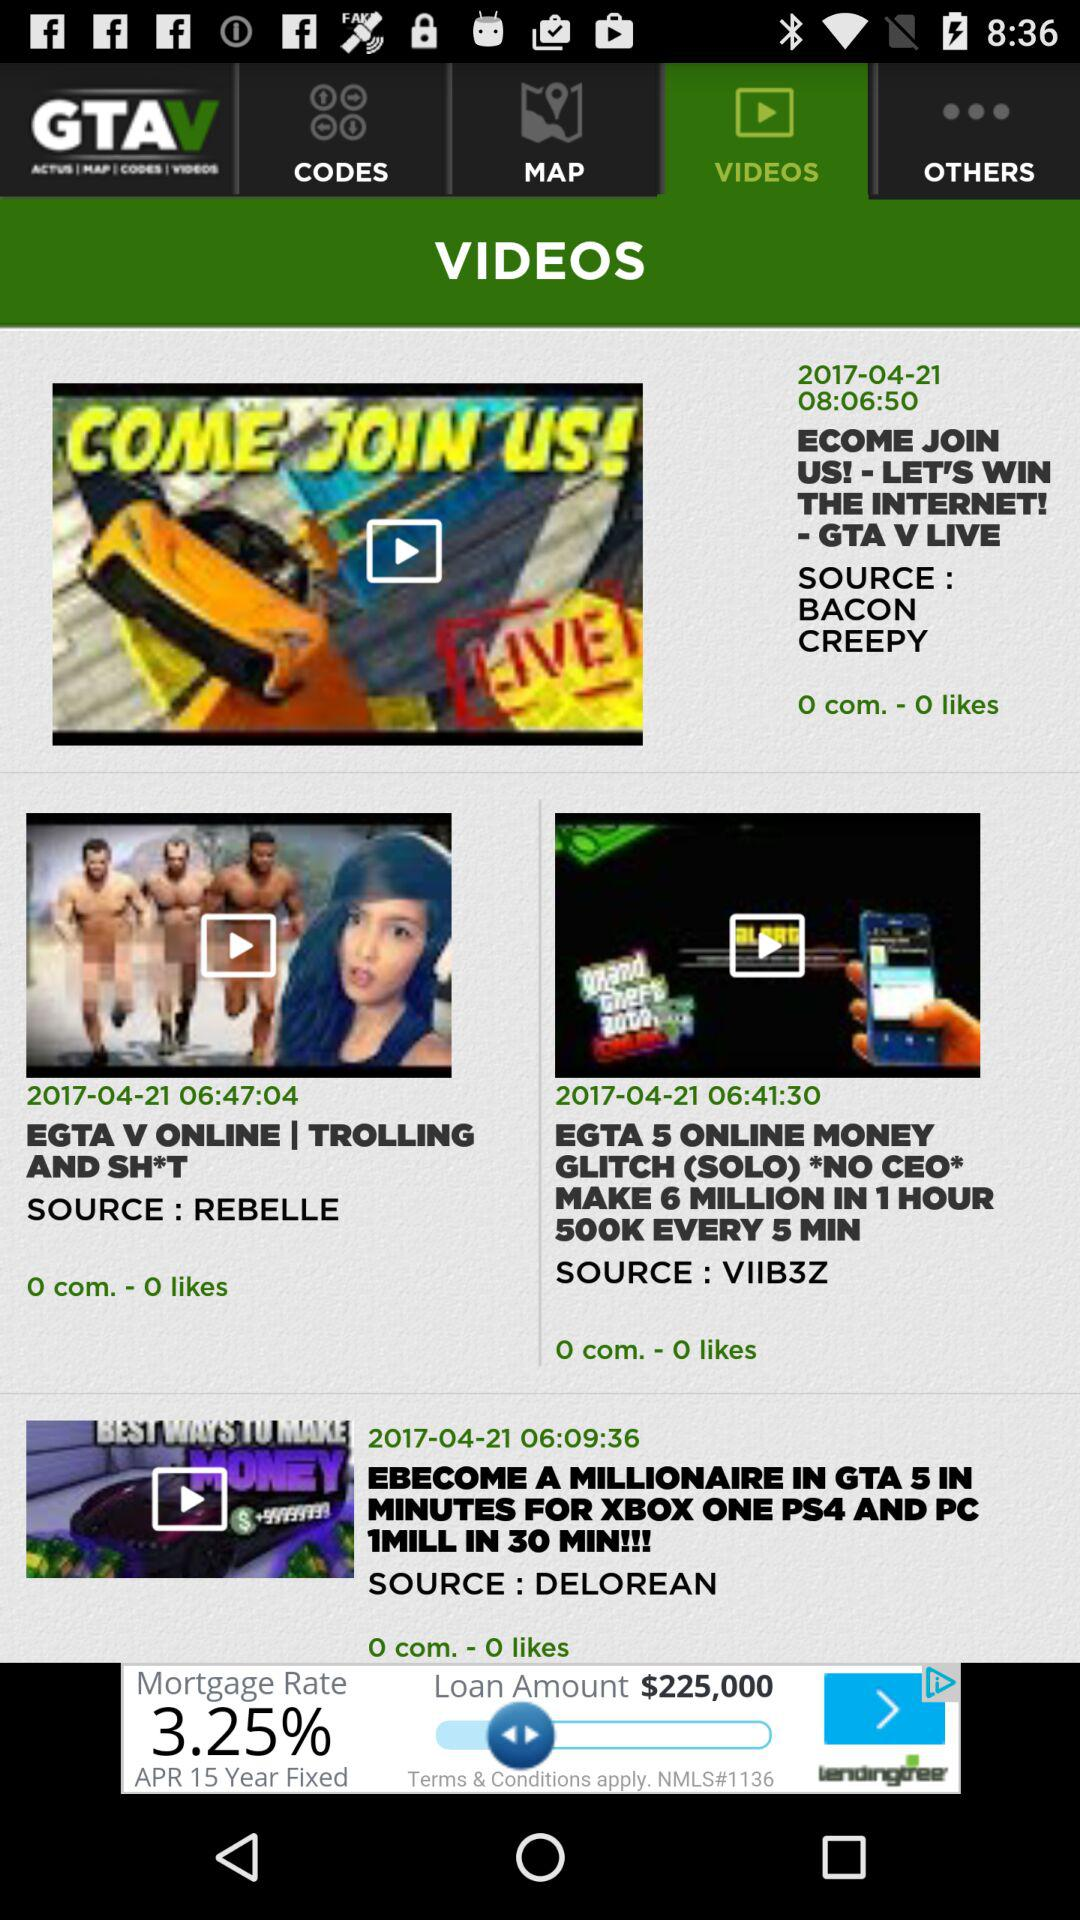What is the duration of the video named "ECOME JOIN US!"? The duration is 8 hours 6 minutes 50 seconds. 